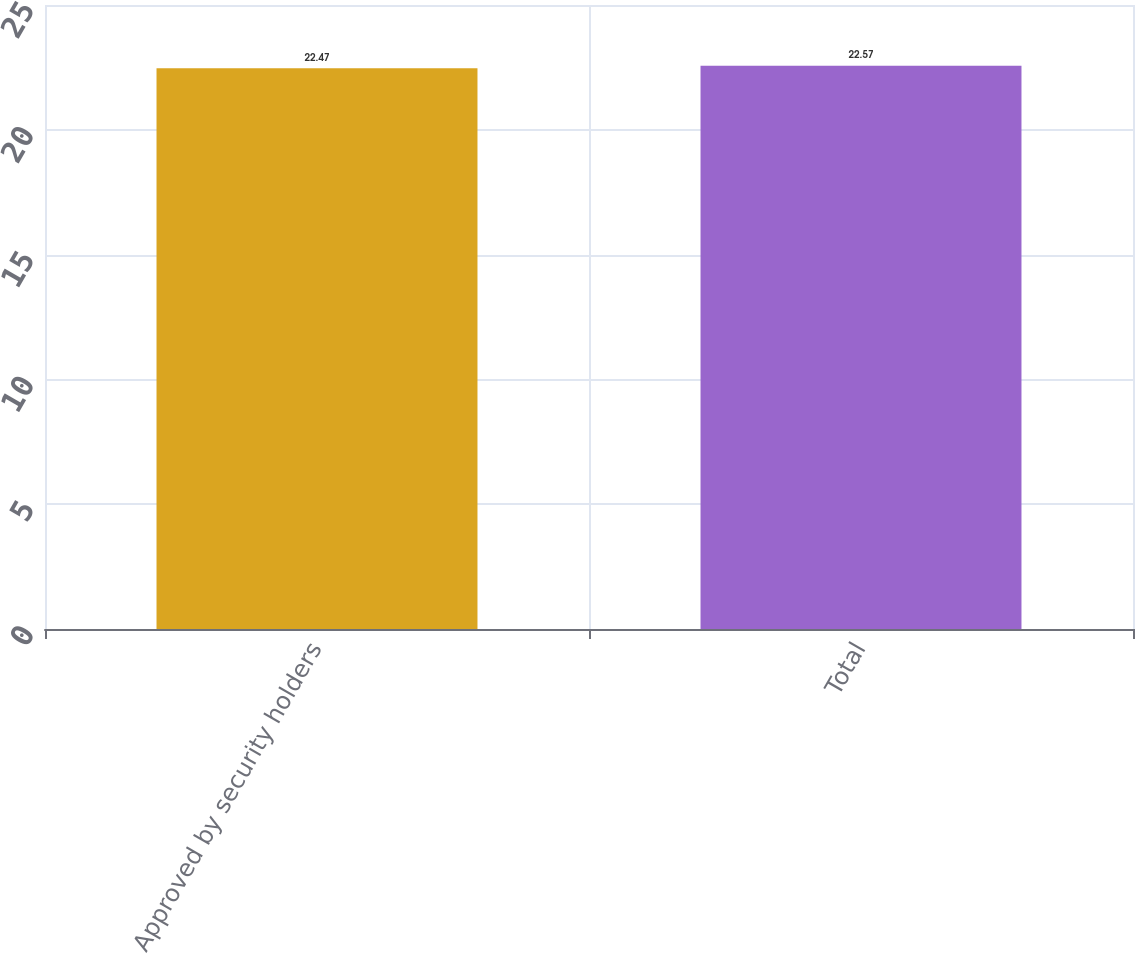Convert chart. <chart><loc_0><loc_0><loc_500><loc_500><bar_chart><fcel>Approved by security holders<fcel>Total<nl><fcel>22.47<fcel>22.57<nl></chart> 